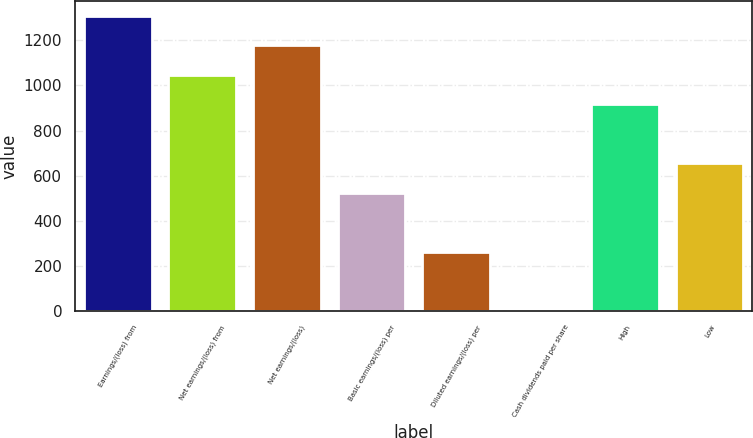<chart> <loc_0><loc_0><loc_500><loc_500><bar_chart><fcel>Earnings/(loss) from<fcel>Net earnings/(loss) from<fcel>Net earnings/(loss)<fcel>Basic earnings/(loss) per<fcel>Diluted earnings/(loss) per<fcel>Cash dividends paid per share<fcel>High<fcel>Low<nl><fcel>1309.01<fcel>1047.28<fcel>1178.14<fcel>523.82<fcel>262.09<fcel>0.35<fcel>916.42<fcel>654.69<nl></chart> 